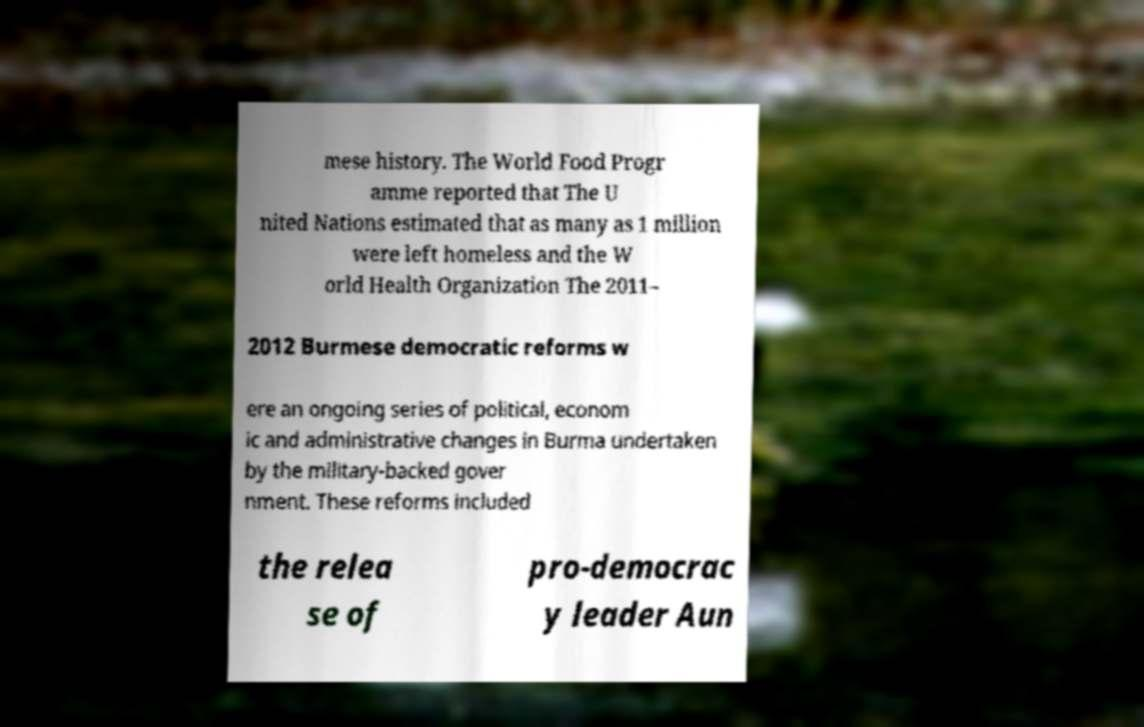Can you read and provide the text displayed in the image?This photo seems to have some interesting text. Can you extract and type it out for me? mese history. The World Food Progr amme reported that The U nited Nations estimated that as many as 1 million were left homeless and the W orld Health Organization The 2011– 2012 Burmese democratic reforms w ere an ongoing series of political, econom ic and administrative changes in Burma undertaken by the military-backed gover nment. These reforms included the relea se of pro-democrac y leader Aun 